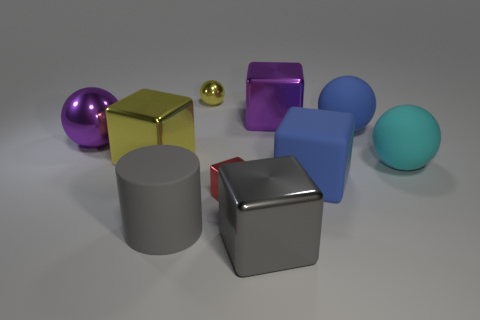Subtract all yellow cubes. How many cubes are left? 4 Subtract all small red cubes. How many cubes are left? 4 Subtract all green cubes. Subtract all green cylinders. How many cubes are left? 5 Subtract all spheres. How many objects are left? 6 Subtract 0 brown balls. How many objects are left? 10 Subtract all big purple metal cubes. Subtract all purple metallic spheres. How many objects are left? 8 Add 4 blue spheres. How many blue spheres are left? 5 Add 3 big yellow matte spheres. How many big yellow matte spheres exist? 3 